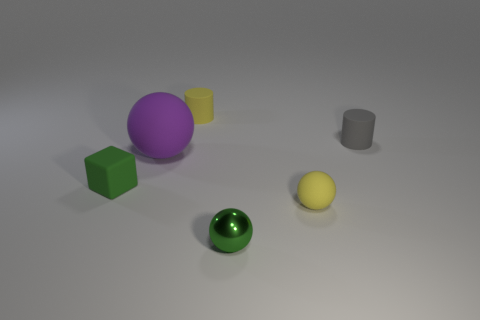Can you describe the composition of this image and what it might suggest? The composition of the image seems deliberately arranged with a variety of geometric shapes and colors. There is a balance between the spread-out placement of objects and a centralized grouping, which might suggest an intentional study on spatial relationships and color theory. It conveys a sense of simplicity and order, often seen in visual demonstrations or educational material. 